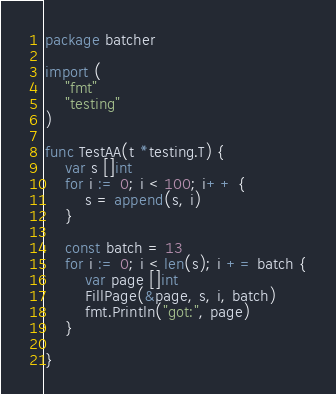Convert code to text. <code><loc_0><loc_0><loc_500><loc_500><_Go_>package batcher

import (
	"fmt"
	"testing"
)

func TestAA(t *testing.T) {
	var s []int
	for i := 0; i < 100; i++ {
		s = append(s, i)
	}

	const batch = 13
	for i := 0; i < len(s); i += batch {
		var page []int
		FillPage(&page, s, i, batch)
		fmt.Println("got:", page)
	}

}
</code> 